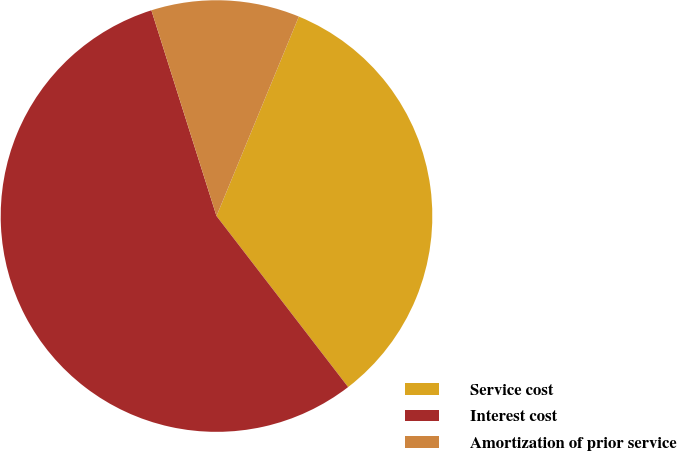<chart> <loc_0><loc_0><loc_500><loc_500><pie_chart><fcel>Service cost<fcel>Interest cost<fcel>Amortization of prior service<nl><fcel>33.33%<fcel>55.56%<fcel>11.11%<nl></chart> 